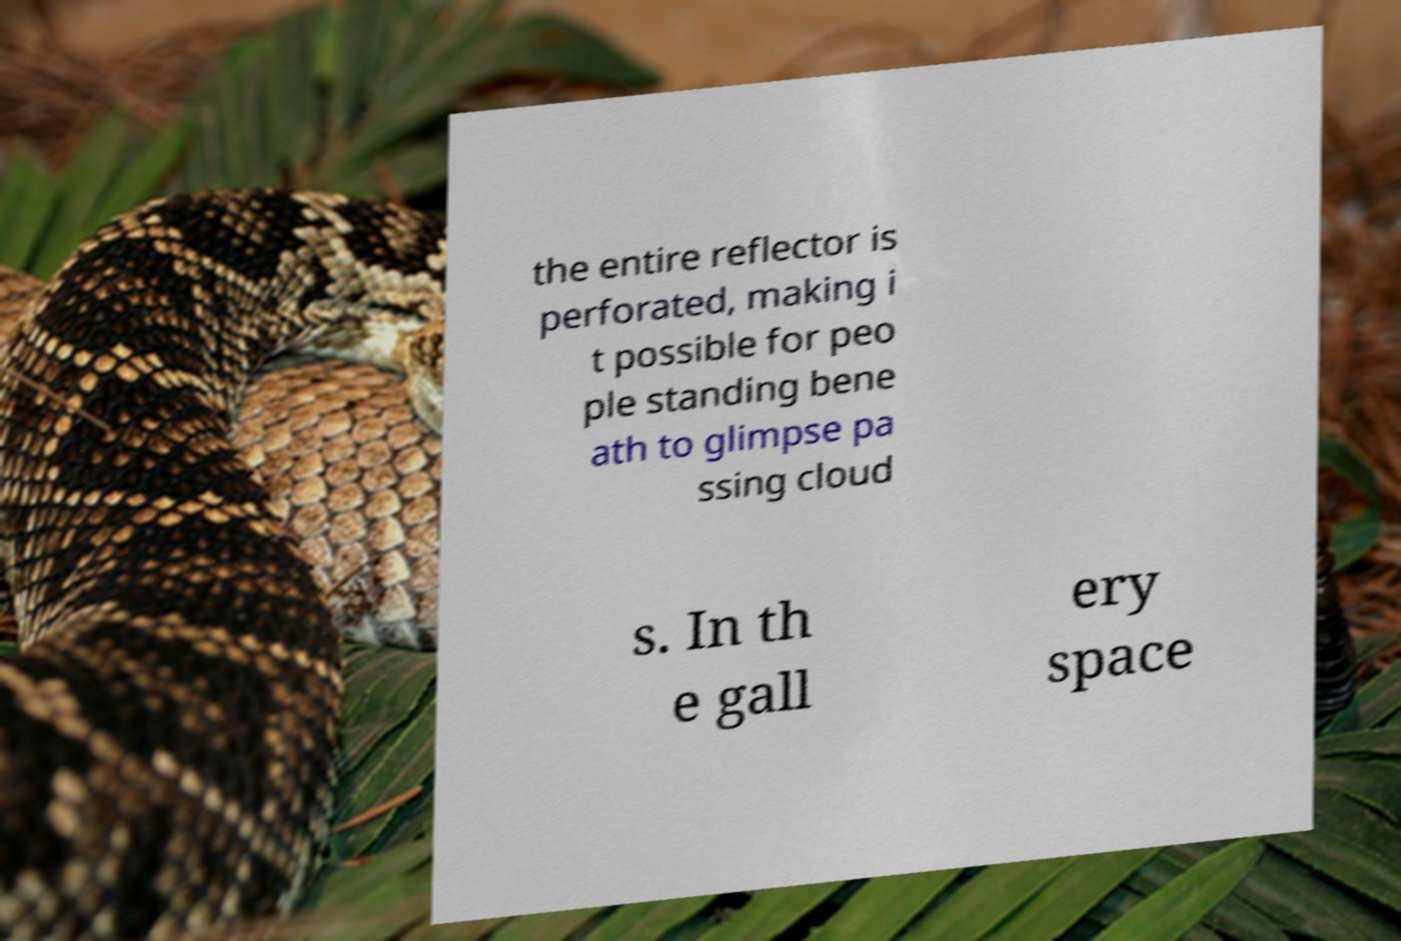What messages or text are displayed in this image? I need them in a readable, typed format. the entire reflector is perforated, making i t possible for peo ple standing bene ath to glimpse pa ssing cloud s. In th e gall ery space 